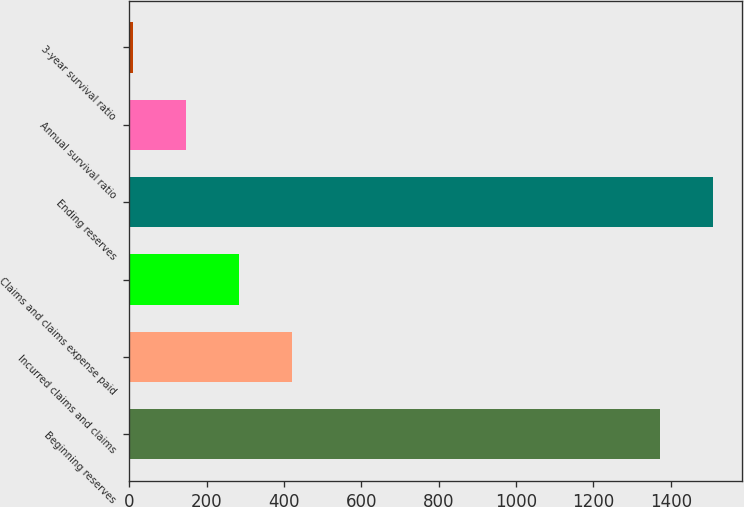Convert chart to OTSL. <chart><loc_0><loc_0><loc_500><loc_500><bar_chart><fcel>Beginning reserves<fcel>Incurred claims and claims<fcel>Claims and claims expense paid<fcel>Ending reserves<fcel>Annual survival ratio<fcel>3-year survival ratio<nl><fcel>1373<fcel>419.85<fcel>283.4<fcel>1509.45<fcel>146.95<fcel>10.5<nl></chart> 